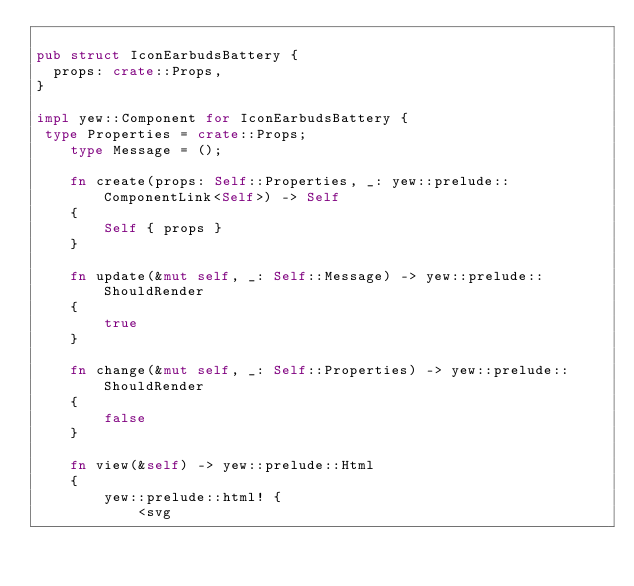Convert code to text. <code><loc_0><loc_0><loc_500><loc_500><_Rust_>
pub struct IconEarbudsBattery {
  props: crate::Props,
}

impl yew::Component for IconEarbudsBattery {
 type Properties = crate::Props;
    type Message = ();

    fn create(props: Self::Properties, _: yew::prelude::ComponentLink<Self>) -> Self
    {
        Self { props }
    }

    fn update(&mut self, _: Self::Message) -> yew::prelude::ShouldRender
    {
        true
    }

    fn change(&mut self, _: Self::Properties) -> yew::prelude::ShouldRender
    {
        false
    }

    fn view(&self) -> yew::prelude::Html
    {
        yew::prelude::html! {
            <svg</code> 